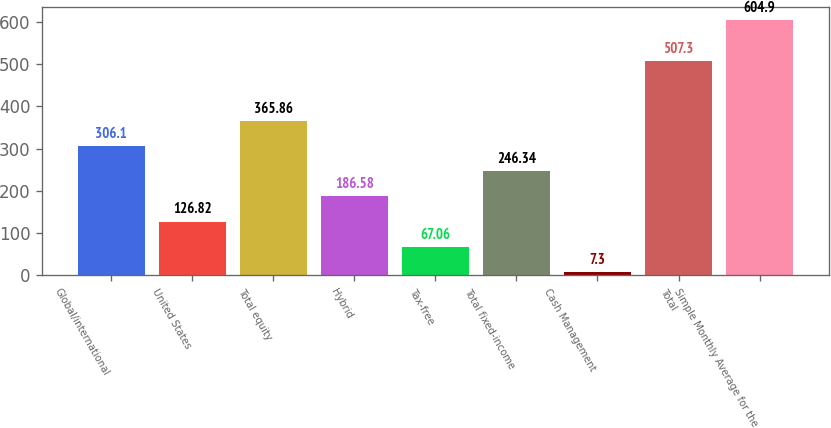Convert chart. <chart><loc_0><loc_0><loc_500><loc_500><bar_chart><fcel>Global/international<fcel>United States<fcel>Total equity<fcel>Hybrid<fcel>Tax-free<fcel>Total fixed-income<fcel>Cash Management<fcel>Total<fcel>Simple Monthly Average for the<nl><fcel>306.1<fcel>126.82<fcel>365.86<fcel>186.58<fcel>67.06<fcel>246.34<fcel>7.3<fcel>507.3<fcel>604.9<nl></chart> 